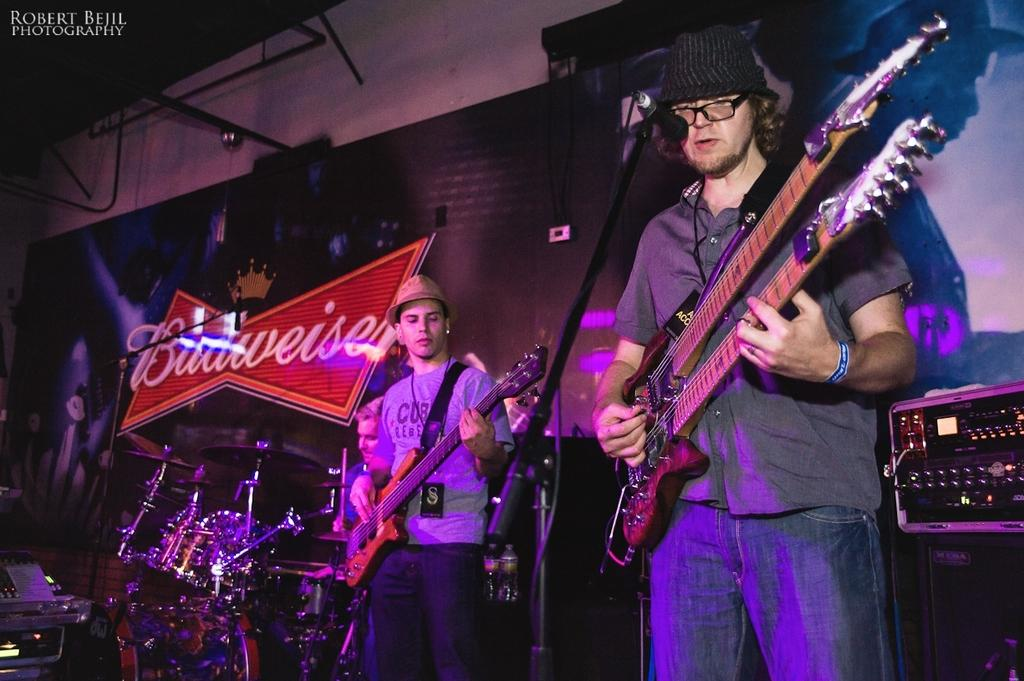What are the men in the image doing? The men in the image are holding guitars. Can you describe the actions of the men in the image? The men are likely playing their guitars, as there is a man in the background playing drums. What instrument is being played by the man in the background? The man in the background is playing drums. What type of health advice can be seen in the image? There is no health advice present in the image; it features men playing guitars and a man playing drums. 